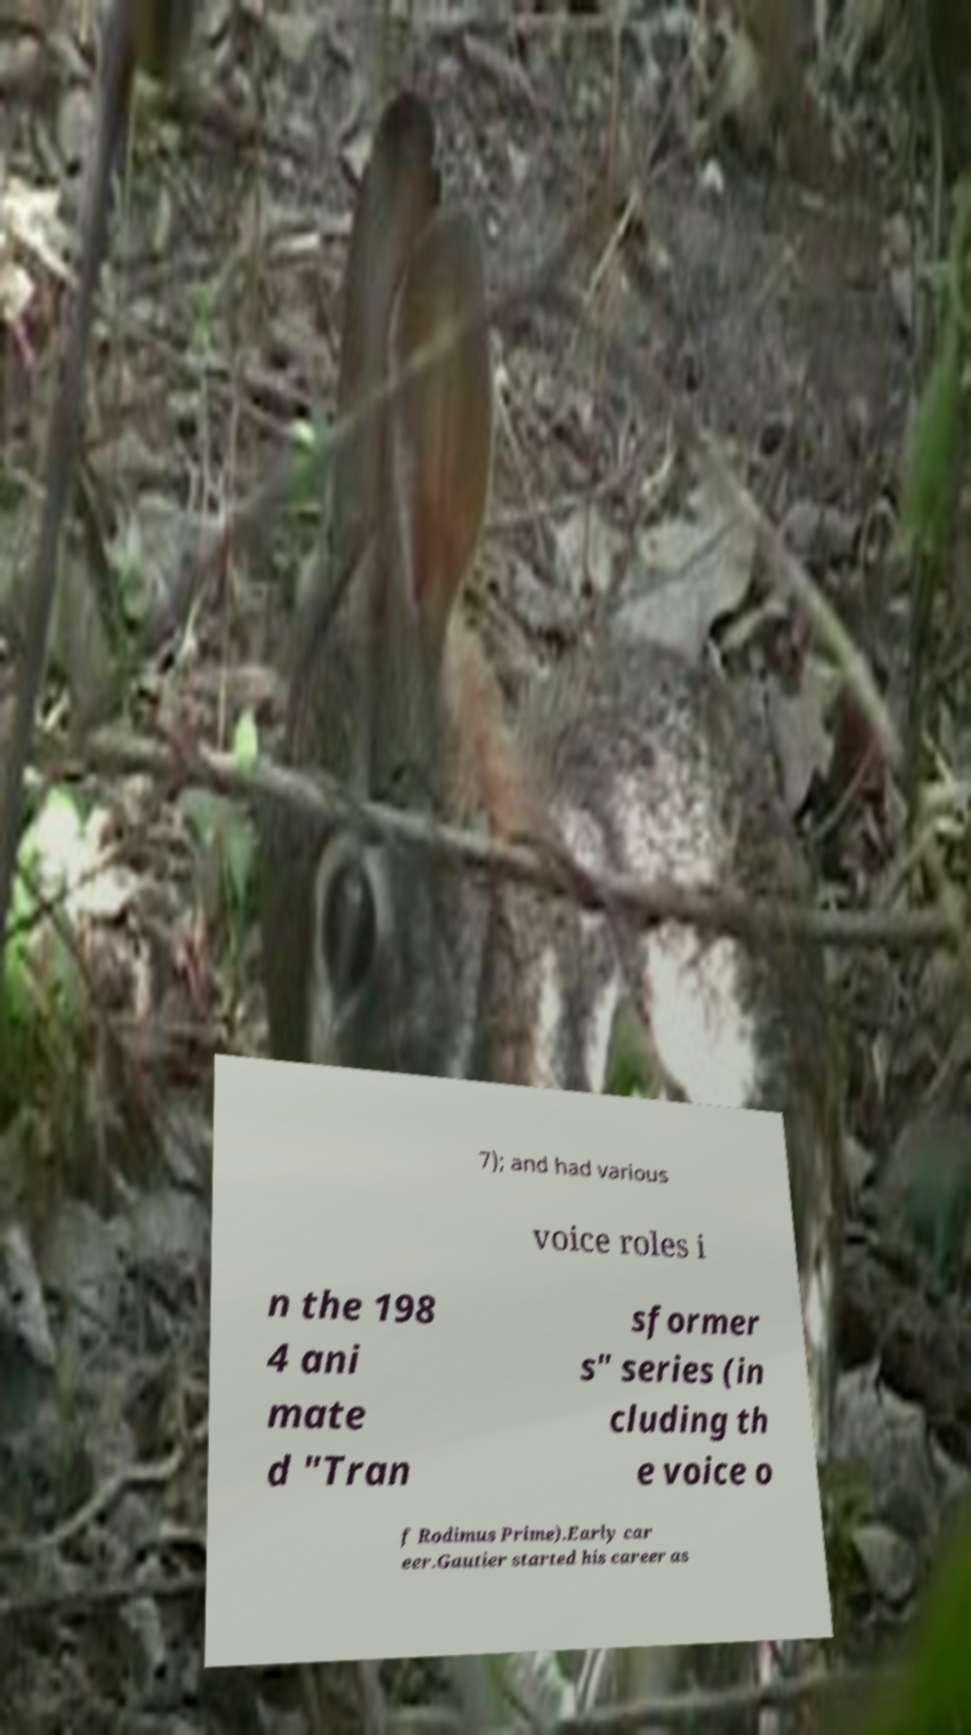There's text embedded in this image that I need extracted. Can you transcribe it verbatim? 7); and had various voice roles i n the 198 4 ani mate d "Tran sformer s" series (in cluding th e voice o f Rodimus Prime).Early car eer.Gautier started his career as 